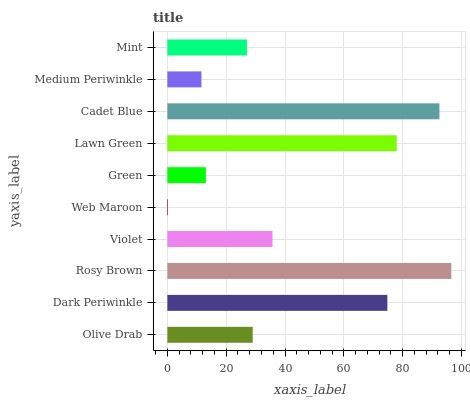Is Web Maroon the minimum?
Answer yes or no. Yes. Is Rosy Brown the maximum?
Answer yes or no. Yes. Is Dark Periwinkle the minimum?
Answer yes or no. No. Is Dark Periwinkle the maximum?
Answer yes or no. No. Is Dark Periwinkle greater than Olive Drab?
Answer yes or no. Yes. Is Olive Drab less than Dark Periwinkle?
Answer yes or no. Yes. Is Olive Drab greater than Dark Periwinkle?
Answer yes or no. No. Is Dark Periwinkle less than Olive Drab?
Answer yes or no. No. Is Violet the high median?
Answer yes or no. Yes. Is Olive Drab the low median?
Answer yes or no. Yes. Is Lawn Green the high median?
Answer yes or no. No. Is Mint the low median?
Answer yes or no. No. 